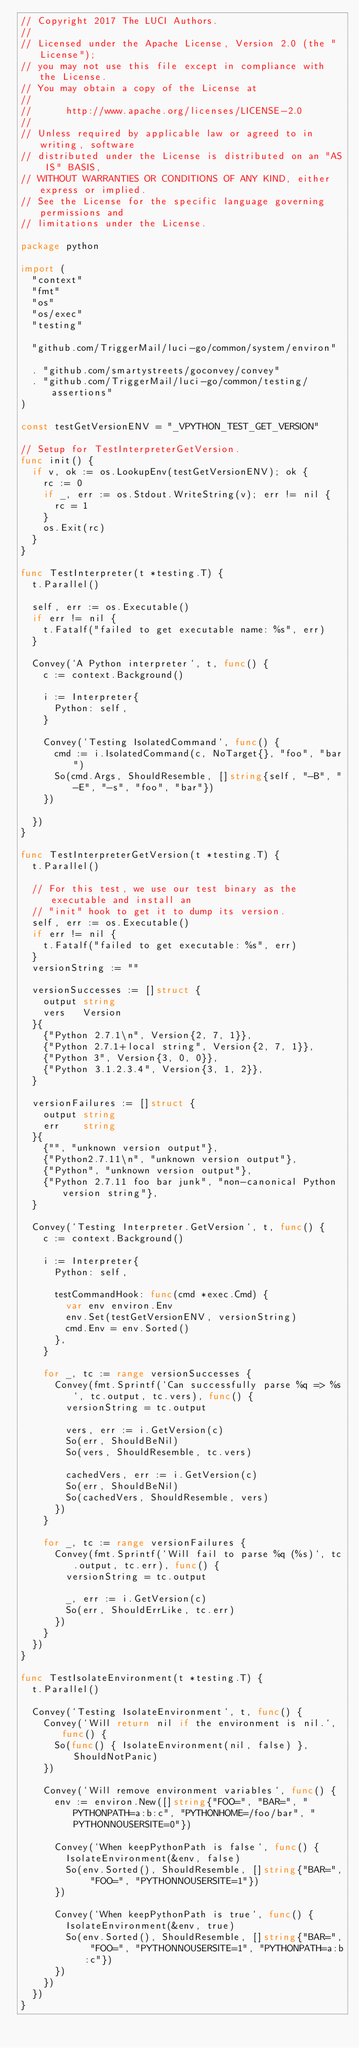Convert code to text. <code><loc_0><loc_0><loc_500><loc_500><_Go_>// Copyright 2017 The LUCI Authors.
//
// Licensed under the Apache License, Version 2.0 (the "License");
// you may not use this file except in compliance with the License.
// You may obtain a copy of the License at
//
//      http://www.apache.org/licenses/LICENSE-2.0
//
// Unless required by applicable law or agreed to in writing, software
// distributed under the License is distributed on an "AS IS" BASIS,
// WITHOUT WARRANTIES OR CONDITIONS OF ANY KIND, either express or implied.
// See the License for the specific language governing permissions and
// limitations under the License.

package python

import (
	"context"
	"fmt"
	"os"
	"os/exec"
	"testing"

	"github.com/TriggerMail/luci-go/common/system/environ"

	. "github.com/smartystreets/goconvey/convey"
	. "github.com/TriggerMail/luci-go/common/testing/assertions"
)

const testGetVersionENV = "_VPYTHON_TEST_GET_VERSION"

// Setup for TestInterpreterGetVersion.
func init() {
	if v, ok := os.LookupEnv(testGetVersionENV); ok {
		rc := 0
		if _, err := os.Stdout.WriteString(v); err != nil {
			rc = 1
		}
		os.Exit(rc)
	}
}

func TestInterpreter(t *testing.T) {
	t.Parallel()

	self, err := os.Executable()
	if err != nil {
		t.Fatalf("failed to get executable name: %s", err)
	}

	Convey(`A Python interpreter`, t, func() {
		c := context.Background()

		i := Interpreter{
			Python: self,
		}

		Convey(`Testing IsolatedCommand`, func() {
			cmd := i.IsolatedCommand(c, NoTarget{}, "foo", "bar")
			So(cmd.Args, ShouldResemble, []string{self, "-B", "-E", "-s", "foo", "bar"})
		})

	})
}

func TestInterpreterGetVersion(t *testing.T) {
	t.Parallel()

	// For this test, we use our test binary as the executable and install an
	// "init" hook to get it to dump its version.
	self, err := os.Executable()
	if err != nil {
		t.Fatalf("failed to get executable: %s", err)
	}
	versionString := ""

	versionSuccesses := []struct {
		output string
		vers   Version
	}{
		{"Python 2.7.1\n", Version{2, 7, 1}},
		{"Python 2.7.1+local string", Version{2, 7, 1}},
		{"Python 3", Version{3, 0, 0}},
		{"Python 3.1.2.3.4", Version{3, 1, 2}},
	}

	versionFailures := []struct {
		output string
		err    string
	}{
		{"", "unknown version output"},
		{"Python2.7.11\n", "unknown version output"},
		{"Python", "unknown version output"},
		{"Python 2.7.11 foo bar junk", "non-canonical Python version string"},
	}

	Convey(`Testing Interpreter.GetVersion`, t, func() {
		c := context.Background()

		i := Interpreter{
			Python: self,

			testCommandHook: func(cmd *exec.Cmd) {
				var env environ.Env
				env.Set(testGetVersionENV, versionString)
				cmd.Env = env.Sorted()
			},
		}

		for _, tc := range versionSuccesses {
			Convey(fmt.Sprintf(`Can successfully parse %q => %s`, tc.output, tc.vers), func() {
				versionString = tc.output

				vers, err := i.GetVersion(c)
				So(err, ShouldBeNil)
				So(vers, ShouldResemble, tc.vers)

				cachedVers, err := i.GetVersion(c)
				So(err, ShouldBeNil)
				So(cachedVers, ShouldResemble, vers)
			})
		}

		for _, tc := range versionFailures {
			Convey(fmt.Sprintf(`Will fail to parse %q (%s)`, tc.output, tc.err), func() {
				versionString = tc.output

				_, err := i.GetVersion(c)
				So(err, ShouldErrLike, tc.err)
			})
		}
	})
}

func TestIsolateEnvironment(t *testing.T) {
	t.Parallel()

	Convey(`Testing IsolateEnvironment`, t, func() {
		Convey(`Will return nil if the environment is nil.`, func() {
			So(func() { IsolateEnvironment(nil, false) }, ShouldNotPanic)
		})

		Convey(`Will remove environment variables`, func() {
			env := environ.New([]string{"FOO=", "BAR=", "PYTHONPATH=a:b:c", "PYTHONHOME=/foo/bar", "PYTHONNOUSERSITE=0"})

			Convey(`When keepPythonPath is false`, func() {
				IsolateEnvironment(&env, false)
				So(env.Sorted(), ShouldResemble, []string{"BAR=", "FOO=", "PYTHONNOUSERSITE=1"})
			})

			Convey(`When keepPythonPath is true`, func() {
				IsolateEnvironment(&env, true)
				So(env.Sorted(), ShouldResemble, []string{"BAR=", "FOO=", "PYTHONNOUSERSITE=1", "PYTHONPATH=a:b:c"})
			})
		})
	})
}
</code> 